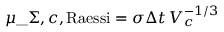Convert formula to latex. <formula><loc_0><loc_0><loc_500><loc_500>\mu \_ { \Sigma , c , R a e s s i } = \sigma \Delta t \, V _ { c } ^ { - 1 / 3 }</formula> 